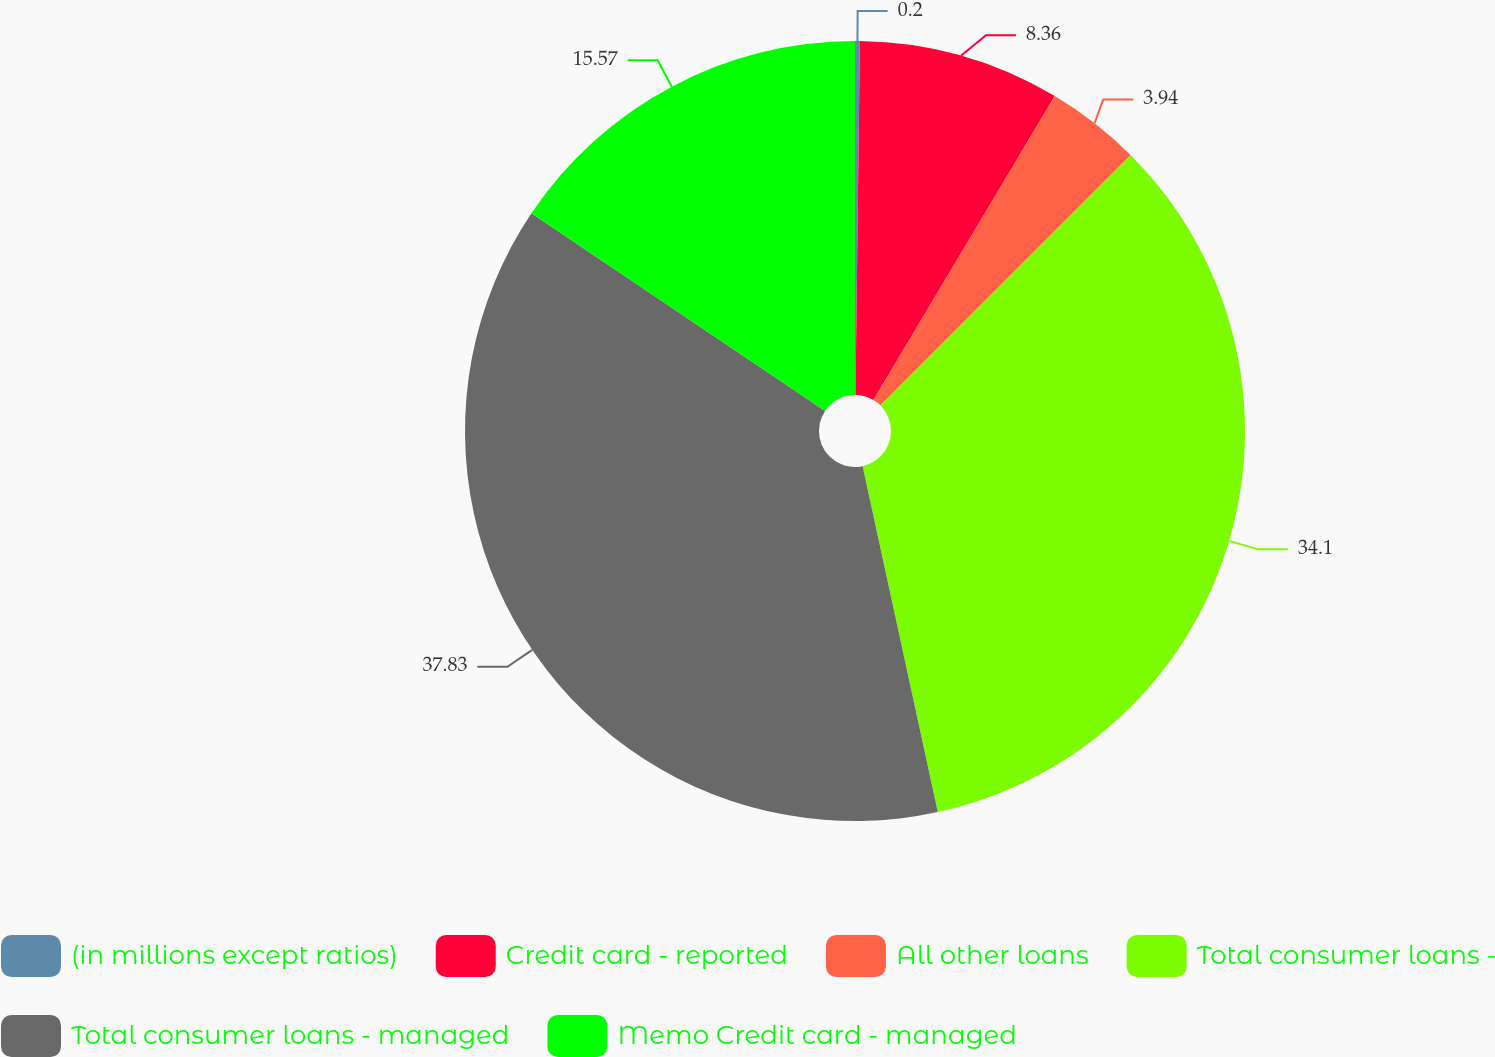<chart> <loc_0><loc_0><loc_500><loc_500><pie_chart><fcel>(in millions except ratios)<fcel>Credit card - reported<fcel>All other loans<fcel>Total consumer loans -<fcel>Total consumer loans - managed<fcel>Memo Credit card - managed<nl><fcel>0.2%<fcel>8.36%<fcel>3.94%<fcel>34.1%<fcel>37.84%<fcel>15.57%<nl></chart> 